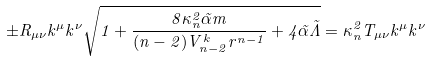<formula> <loc_0><loc_0><loc_500><loc_500>\pm R _ { \mu \nu } k ^ { \mu } k ^ { \nu } \sqrt { 1 + \frac { 8 \kappa _ { n } ^ { 2 } { \tilde { \alpha } } m } { ( n - 2 ) V ^ { k } _ { n - 2 } r ^ { n - 1 } } + 4 { \tilde { \alpha } } { \tilde { \Lambda } } } = \kappa _ { n } ^ { 2 } T _ { \mu \nu } k ^ { \mu } k ^ { \nu }</formula> 